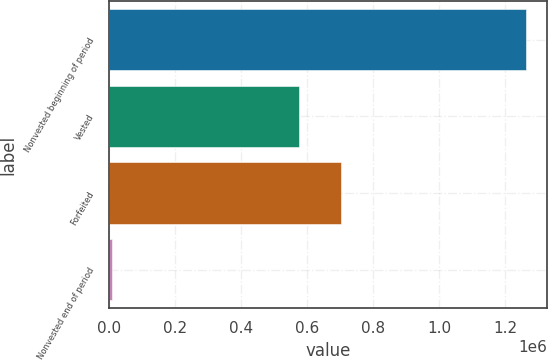Convert chart to OTSL. <chart><loc_0><loc_0><loc_500><loc_500><bar_chart><fcel>Nonvested beginning of period<fcel>Vested<fcel>Forfeited<fcel>Nonvested end of period<nl><fcel>1.2635e+06<fcel>575890<fcel>701490<fcel>7500<nl></chart> 